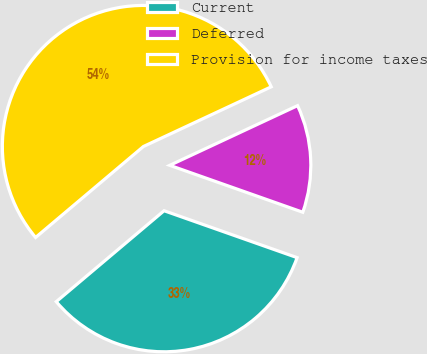Convert chart. <chart><loc_0><loc_0><loc_500><loc_500><pie_chart><fcel>Current<fcel>Deferred<fcel>Provision for income taxes<nl><fcel>33.45%<fcel>12.35%<fcel>54.2%<nl></chart> 